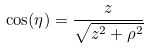<formula> <loc_0><loc_0><loc_500><loc_500>\cos ( \eta ) = { \frac { z } { \sqrt { z ^ { 2 } + \rho ^ { 2 } } } }</formula> 